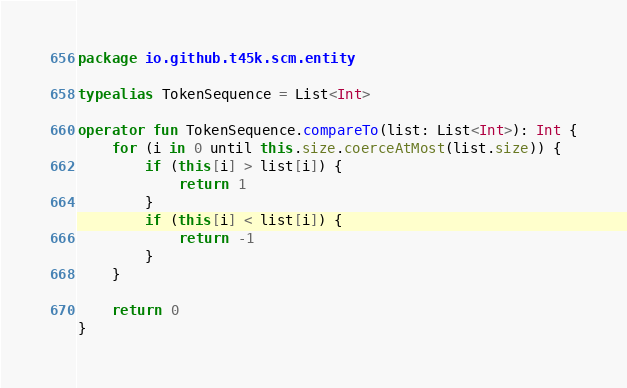Convert code to text. <code><loc_0><loc_0><loc_500><loc_500><_Kotlin_>package io.github.t45k.scm.entity

typealias TokenSequence = List<Int>

operator fun TokenSequence.compareTo(list: List<Int>): Int {
    for (i in 0 until this.size.coerceAtMost(list.size)) {
        if (this[i] > list[i]) {
            return 1
        }
        if (this[i] < list[i]) {
            return -1
        }
    }

    return 0
}
</code> 